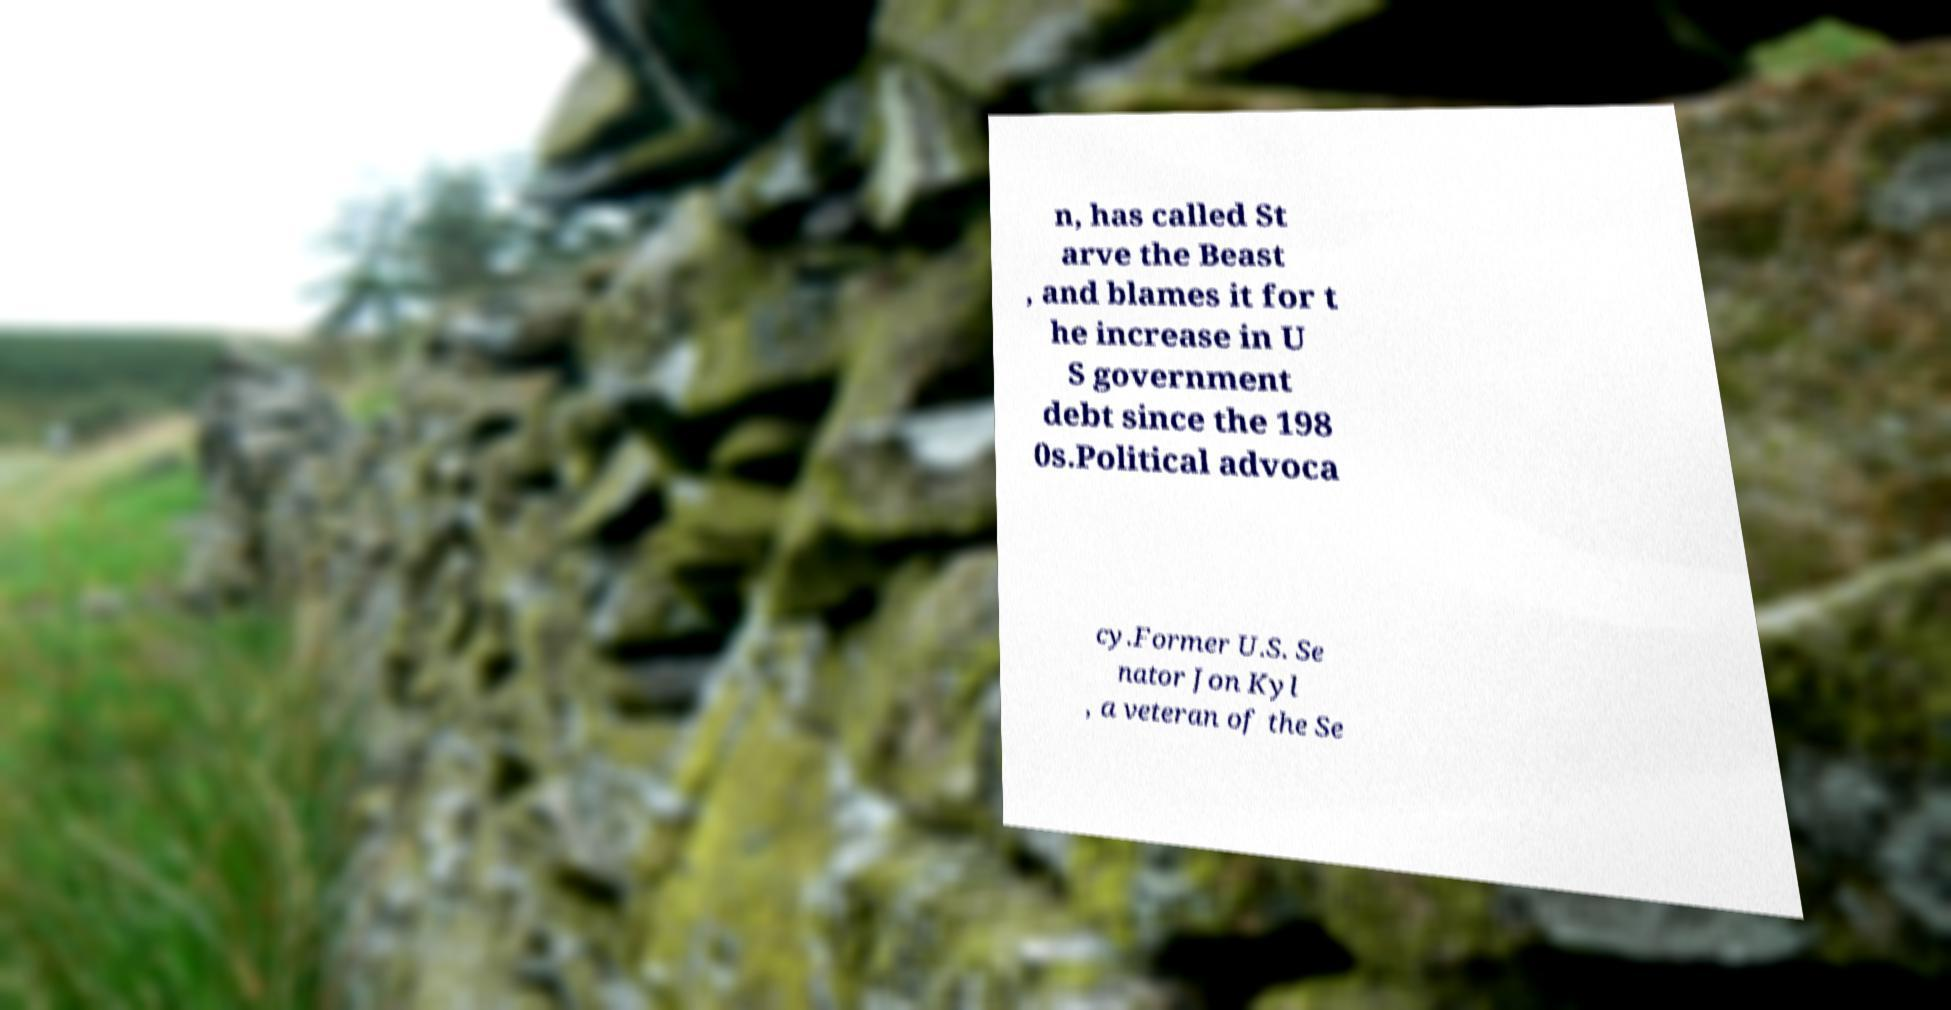Could you assist in decoding the text presented in this image and type it out clearly? n, has called St arve the Beast , and blames it for t he increase in U S government debt since the 198 0s.Political advoca cy.Former U.S. Se nator Jon Kyl , a veteran of the Se 